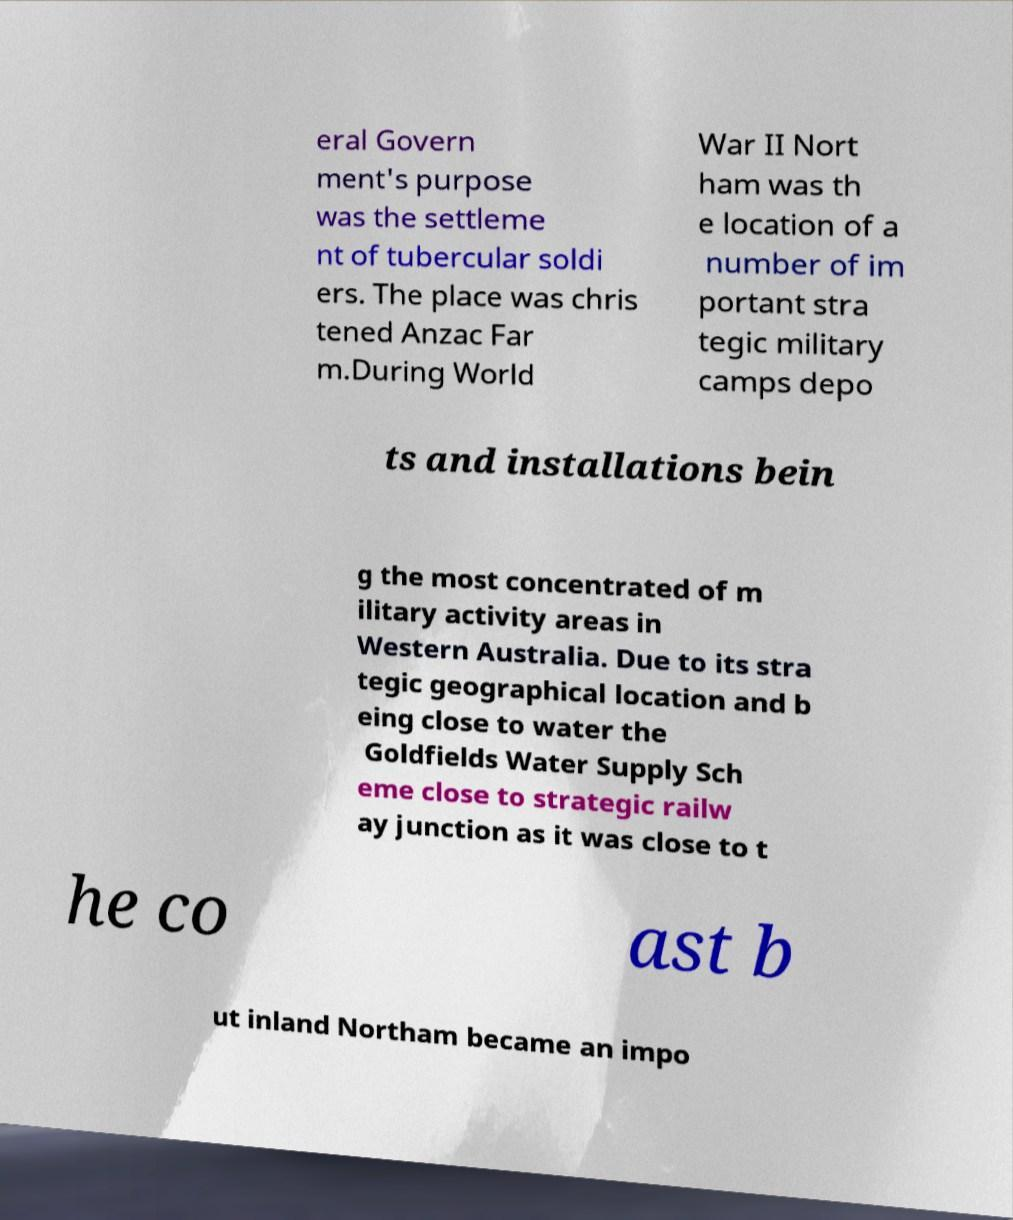Could you extract and type out the text from this image? eral Govern ment's purpose was the settleme nt of tubercular soldi ers. The place was chris tened Anzac Far m.During World War II Nort ham was th e location of a number of im portant stra tegic military camps depo ts and installations bein g the most concentrated of m ilitary activity areas in Western Australia. Due to its stra tegic geographical location and b eing close to water the Goldfields Water Supply Sch eme close to strategic railw ay junction as it was close to t he co ast b ut inland Northam became an impo 